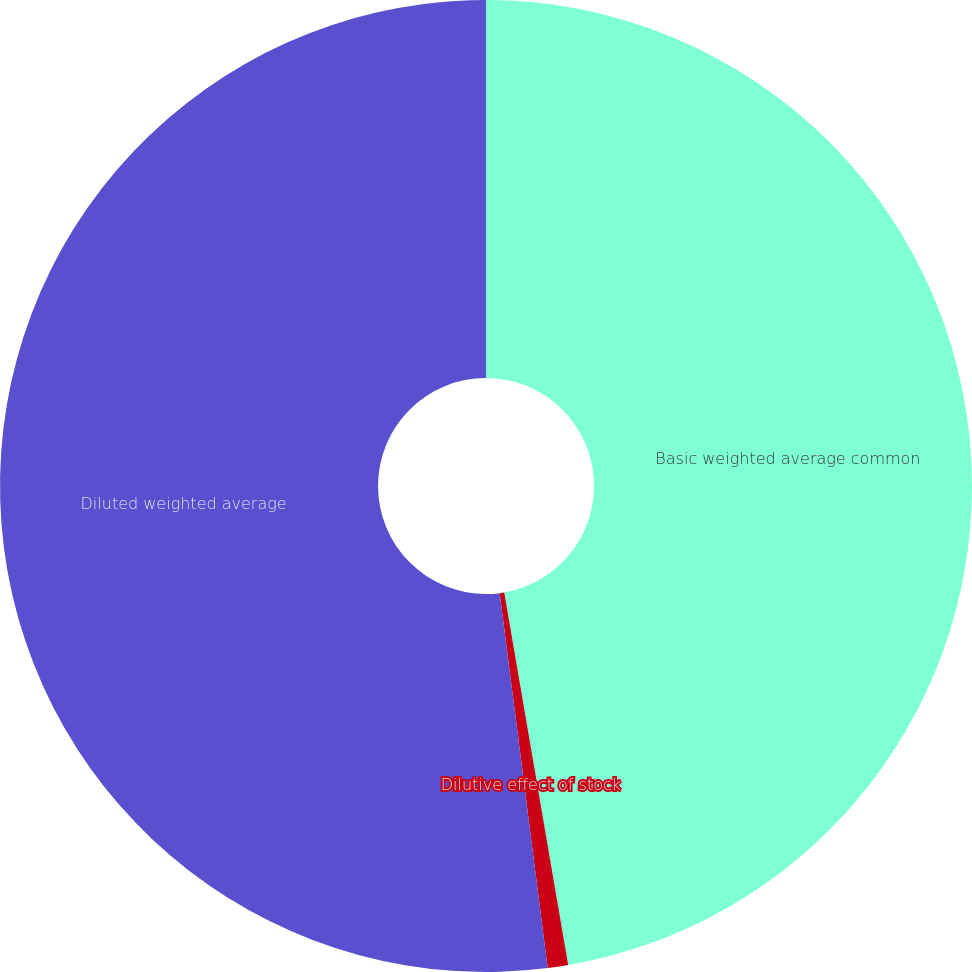<chart> <loc_0><loc_0><loc_500><loc_500><pie_chart><fcel>Basic weighted average common<fcel>Dilutive effect of stock<fcel>Diluted weighted average<nl><fcel>47.29%<fcel>0.68%<fcel>52.02%<nl></chart> 